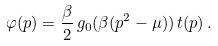<formula> <loc_0><loc_0><loc_500><loc_500>\varphi ( p ) = \frac { \beta } { 2 } \, g _ { 0 } ( \beta ( p ^ { 2 } - \mu ) ) \, t ( p ) \, .</formula> 